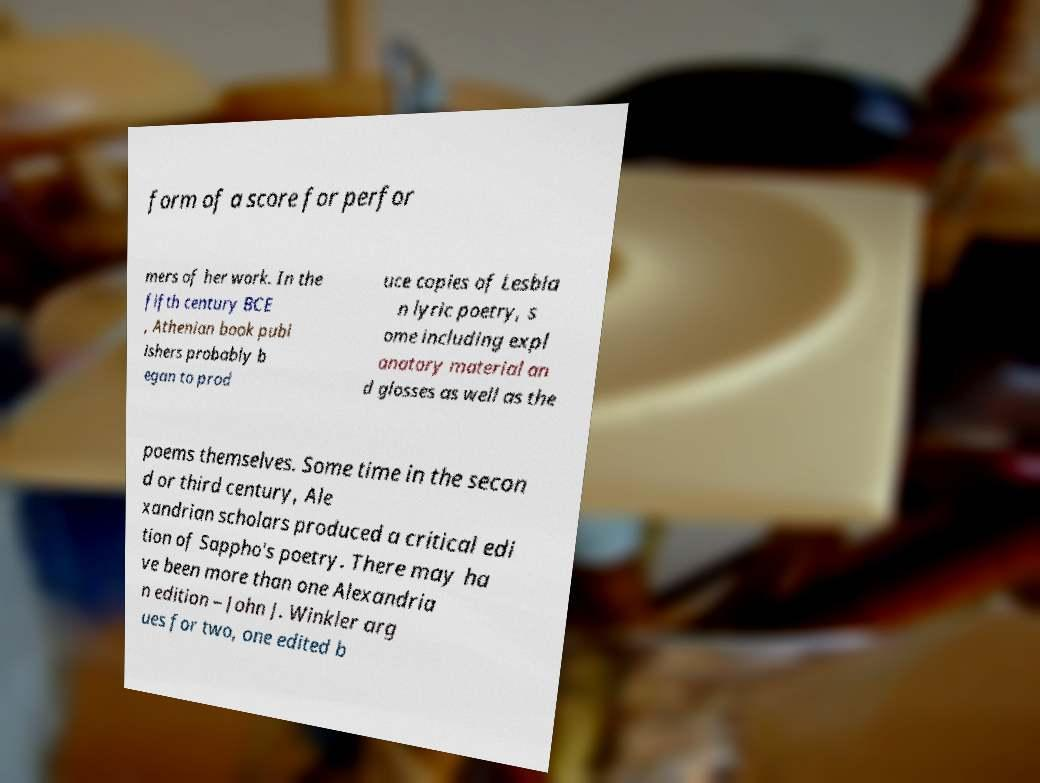What messages or text are displayed in this image? I need them in a readable, typed format. form of a score for perfor mers of her work. In the fifth century BCE , Athenian book publ ishers probably b egan to prod uce copies of Lesbia n lyric poetry, s ome including expl anatory material an d glosses as well as the poems themselves. Some time in the secon d or third century, Ale xandrian scholars produced a critical edi tion of Sappho's poetry. There may ha ve been more than one Alexandria n edition – John J. Winkler arg ues for two, one edited b 